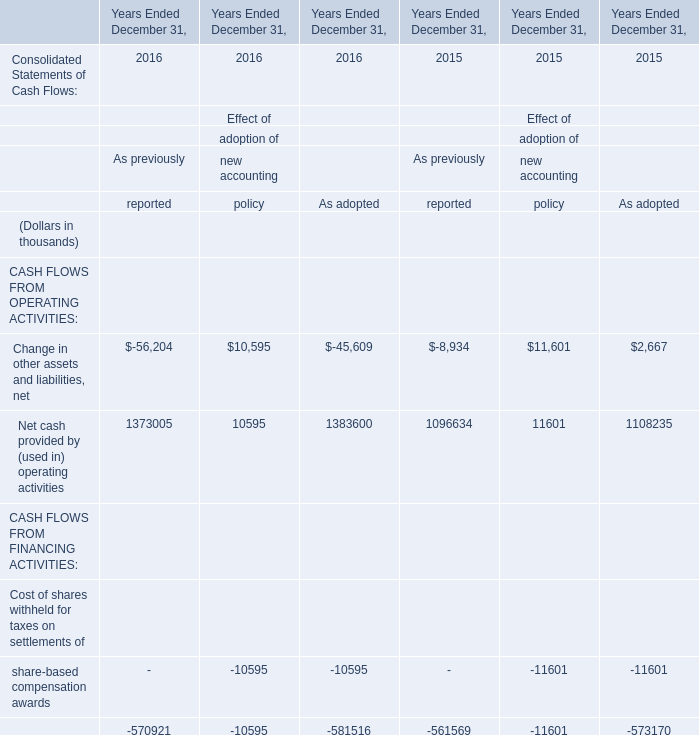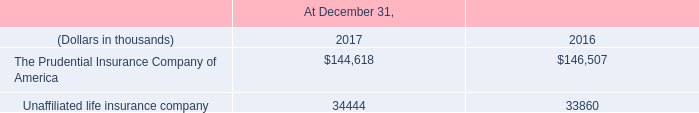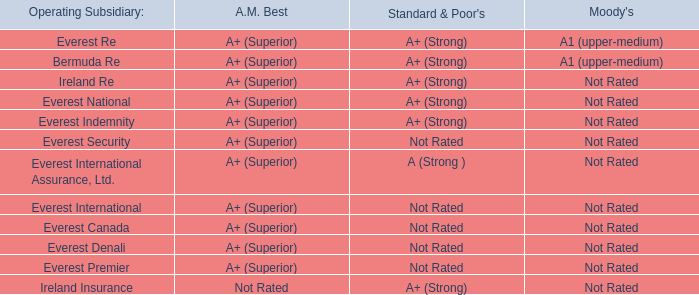Which year is Net cash provided by (used in) operating activities the most for As previously? 
Answer: 2016. 